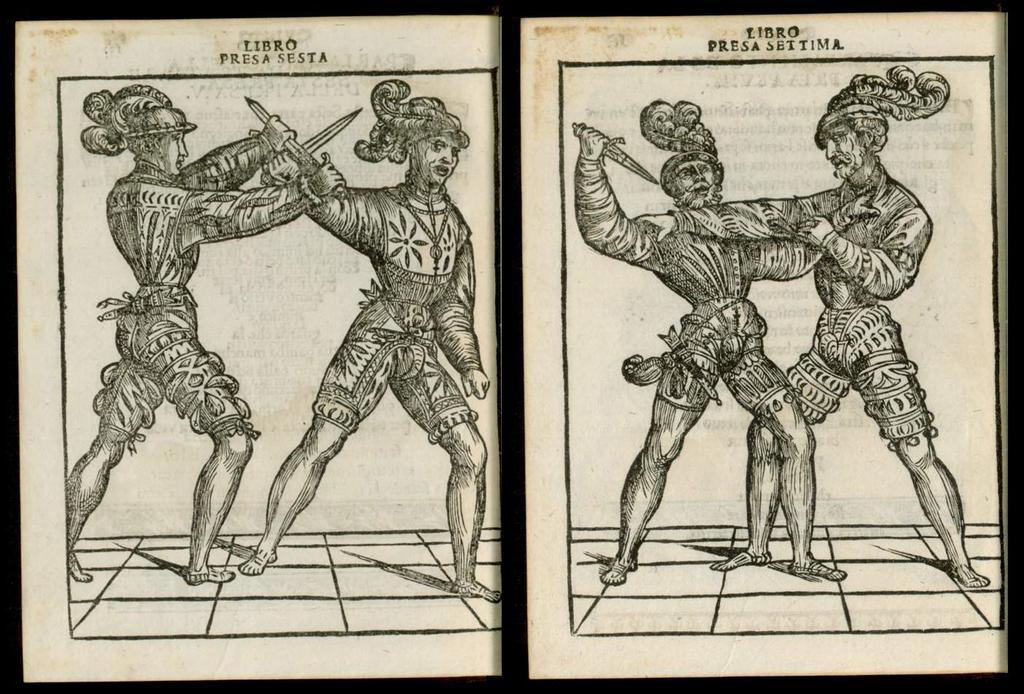Please provide a concise description of this image. In the given image there are two persons who are fighting with each other and they have knife in their hands. In the other image of the book one person is trying to stab the another man and this man is trying to save himself and defend. 